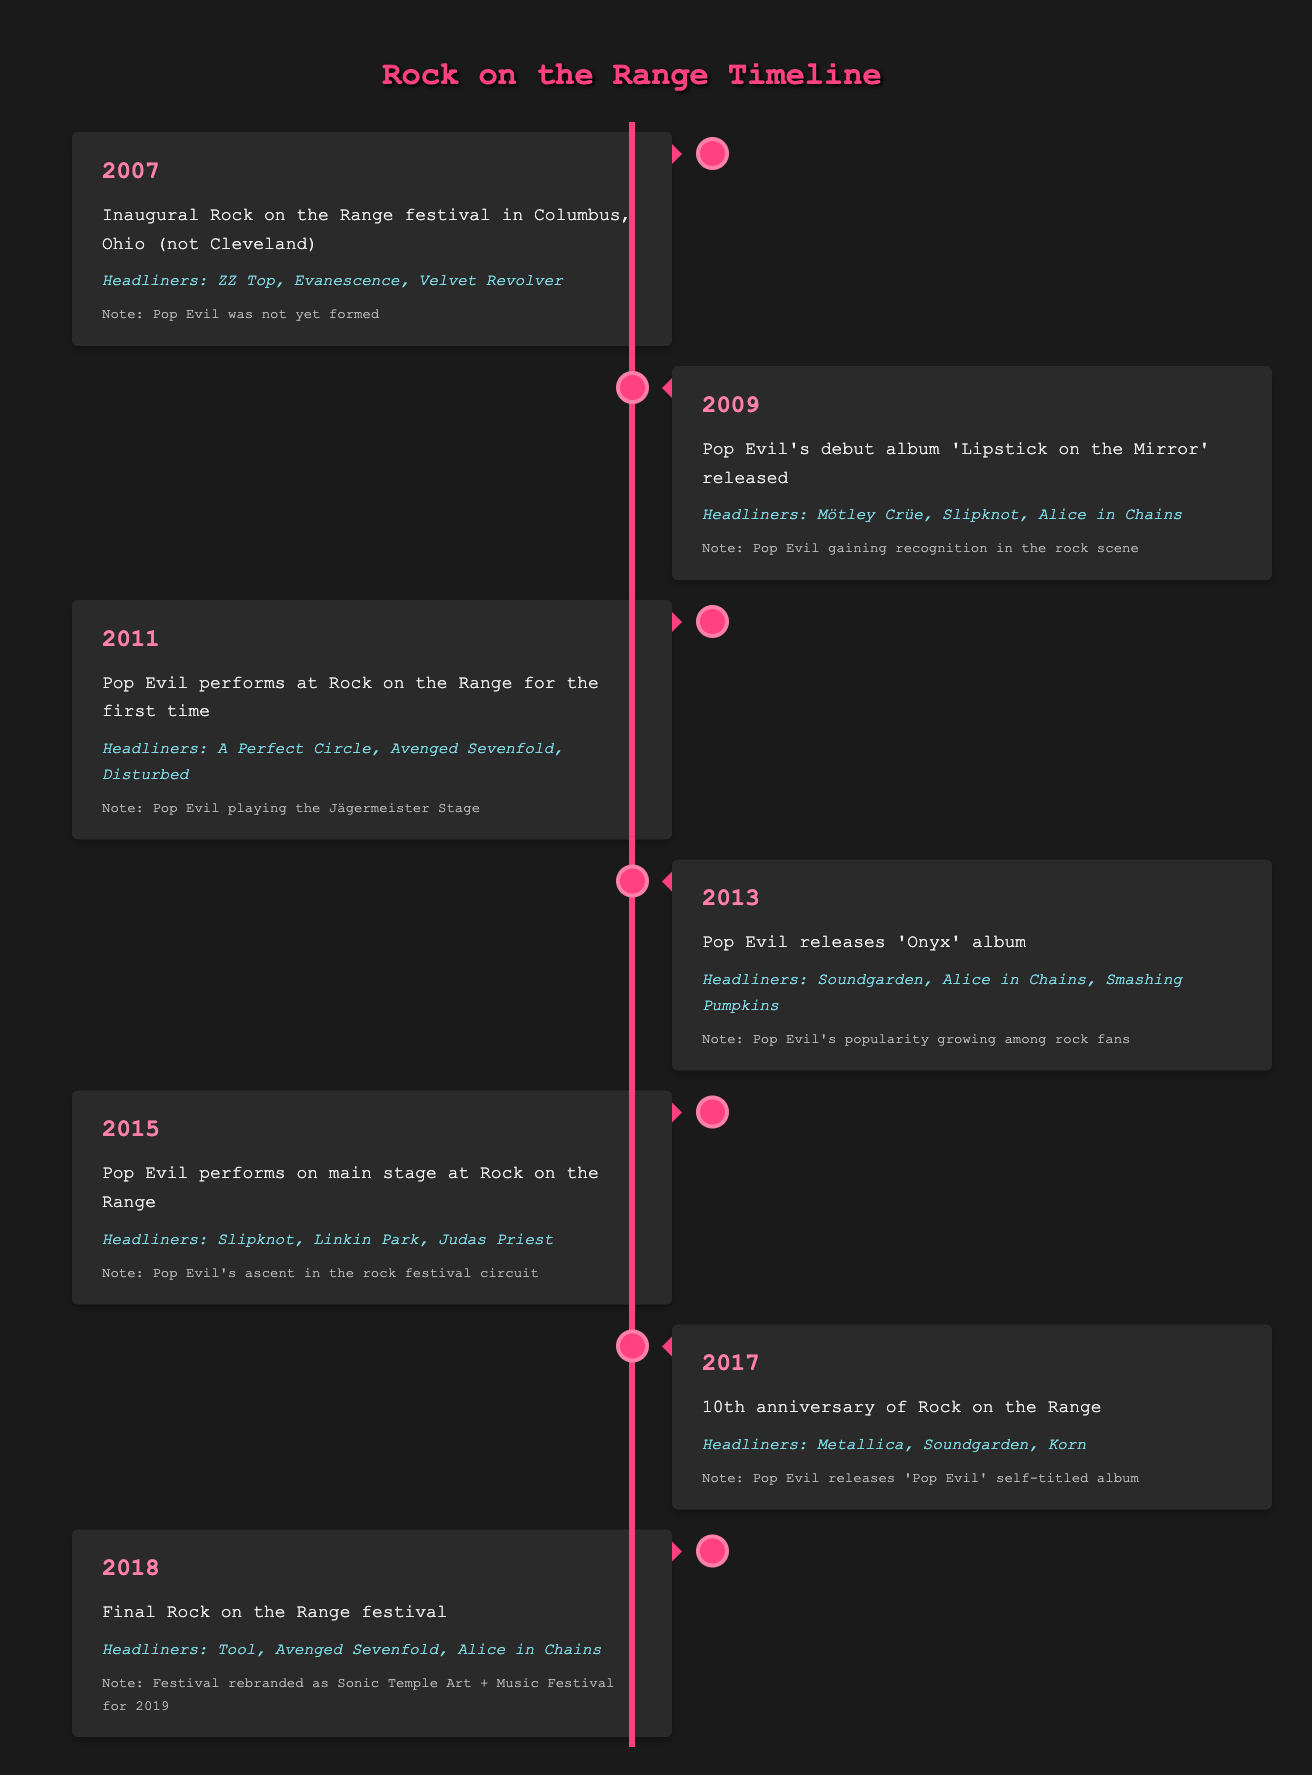What year was the inaugural Rock on the Range festival held? The table lists the inaugural event in the year 2007. Therefore, referring to the timeline events, it confirms that this is the correct year when the festival was first held.
Answer: 2007 Which band headlined the Rock on the Range festival in 2013? The headliners for the 2013 event are clearly listed in the corresponding row, which includes Soundgarden, Alice in Chains, and Smashing Pumpkins.
Answer: Soundgarden, Alice in Chains, Smashing Pumpkins Did Pop Evil perform on the main stage at Rock on the Range before 2017? According to the table, it states that Pop Evil performed on the main stage at Rock on the Range in 2015, which is before 2017, indicating that this statement is true.
Answer: Yes What was the note associated with the 2015 Rock on the Range festival? The 2015 row specifies the note as "Pop Evil's ascent in the rock festival circuit." This information is explicitly given in that year’s section, confirming it easily.
Answer: Pop Evil's ascent in the rock festival circuit How many years passed between Pop Evil's debut performance and their performance on the main stage? Pop Evil's debut performance was in 2011, and their performance on the main stage was in 2015. To find the difference, subtract 2011 from 2015, which yields 4 years.
Answer: 4 years How many times did Pop Evil perform at Rock on the Range by 2018? The timeline shows that Pop Evil performed in 2011 and then again in 2015. Since there are only those two years listed, it confirms that they performed twice by 2018.
Answer: 2 times Was the final Rock on the Range festival held in Cleveland? The table indicates that the final Rock on the Range event took place in 2018 in Columbus, Ohio, thus the statement is false since it's not in Cleveland.
Answer: No What were the headliners for the year representing Pop Evil's first performance at the festival? In the year 2011, the headliners listed are A Perfect Circle, Avenged Sevenfold, and Disturbed. This specific data points to the headliners during Pop Evil's initial appearance at Rock on the Range.
Answer: A Perfect Circle, Avenged Sevenfold, Disturbed Which album did Pop Evil release just before their performance at Rock on the Range in 2013? The table shows that Pop Evil released their album "Onyx" in 2013, which directly relates to their performance at the festival that same year, indicating the connection of the timing.
Answer: Onyx 